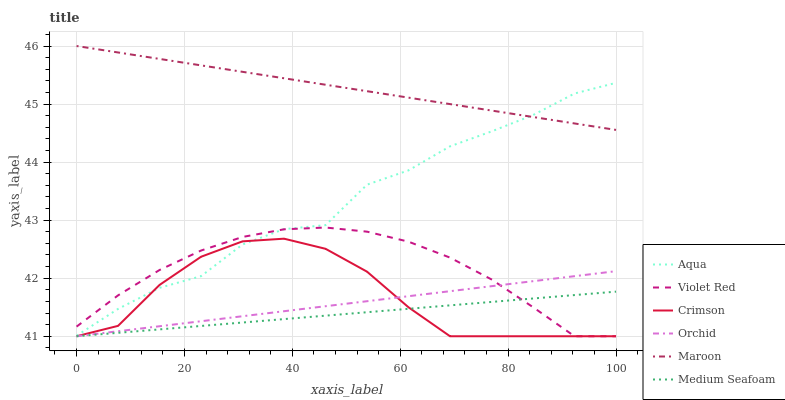Does Aqua have the minimum area under the curve?
Answer yes or no. No. Does Aqua have the maximum area under the curve?
Answer yes or no. No. Is Maroon the smoothest?
Answer yes or no. No. Is Maroon the roughest?
Answer yes or no. No. Does Aqua have the lowest value?
Answer yes or no. No. Does Aqua have the highest value?
Answer yes or no. No. Is Medium Seafoam less than Maroon?
Answer yes or no. Yes. Is Aqua greater than Medium Seafoam?
Answer yes or no. Yes. Does Medium Seafoam intersect Maroon?
Answer yes or no. No. 